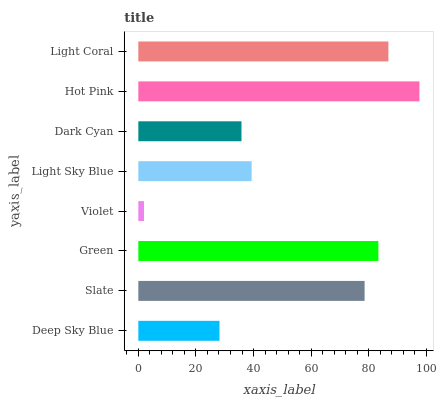Is Violet the minimum?
Answer yes or no. Yes. Is Hot Pink the maximum?
Answer yes or no. Yes. Is Slate the minimum?
Answer yes or no. No. Is Slate the maximum?
Answer yes or no. No. Is Slate greater than Deep Sky Blue?
Answer yes or no. Yes. Is Deep Sky Blue less than Slate?
Answer yes or no. Yes. Is Deep Sky Blue greater than Slate?
Answer yes or no. No. Is Slate less than Deep Sky Blue?
Answer yes or no. No. Is Slate the high median?
Answer yes or no. Yes. Is Light Sky Blue the low median?
Answer yes or no. Yes. Is Light Coral the high median?
Answer yes or no. No. Is Violet the low median?
Answer yes or no. No. 